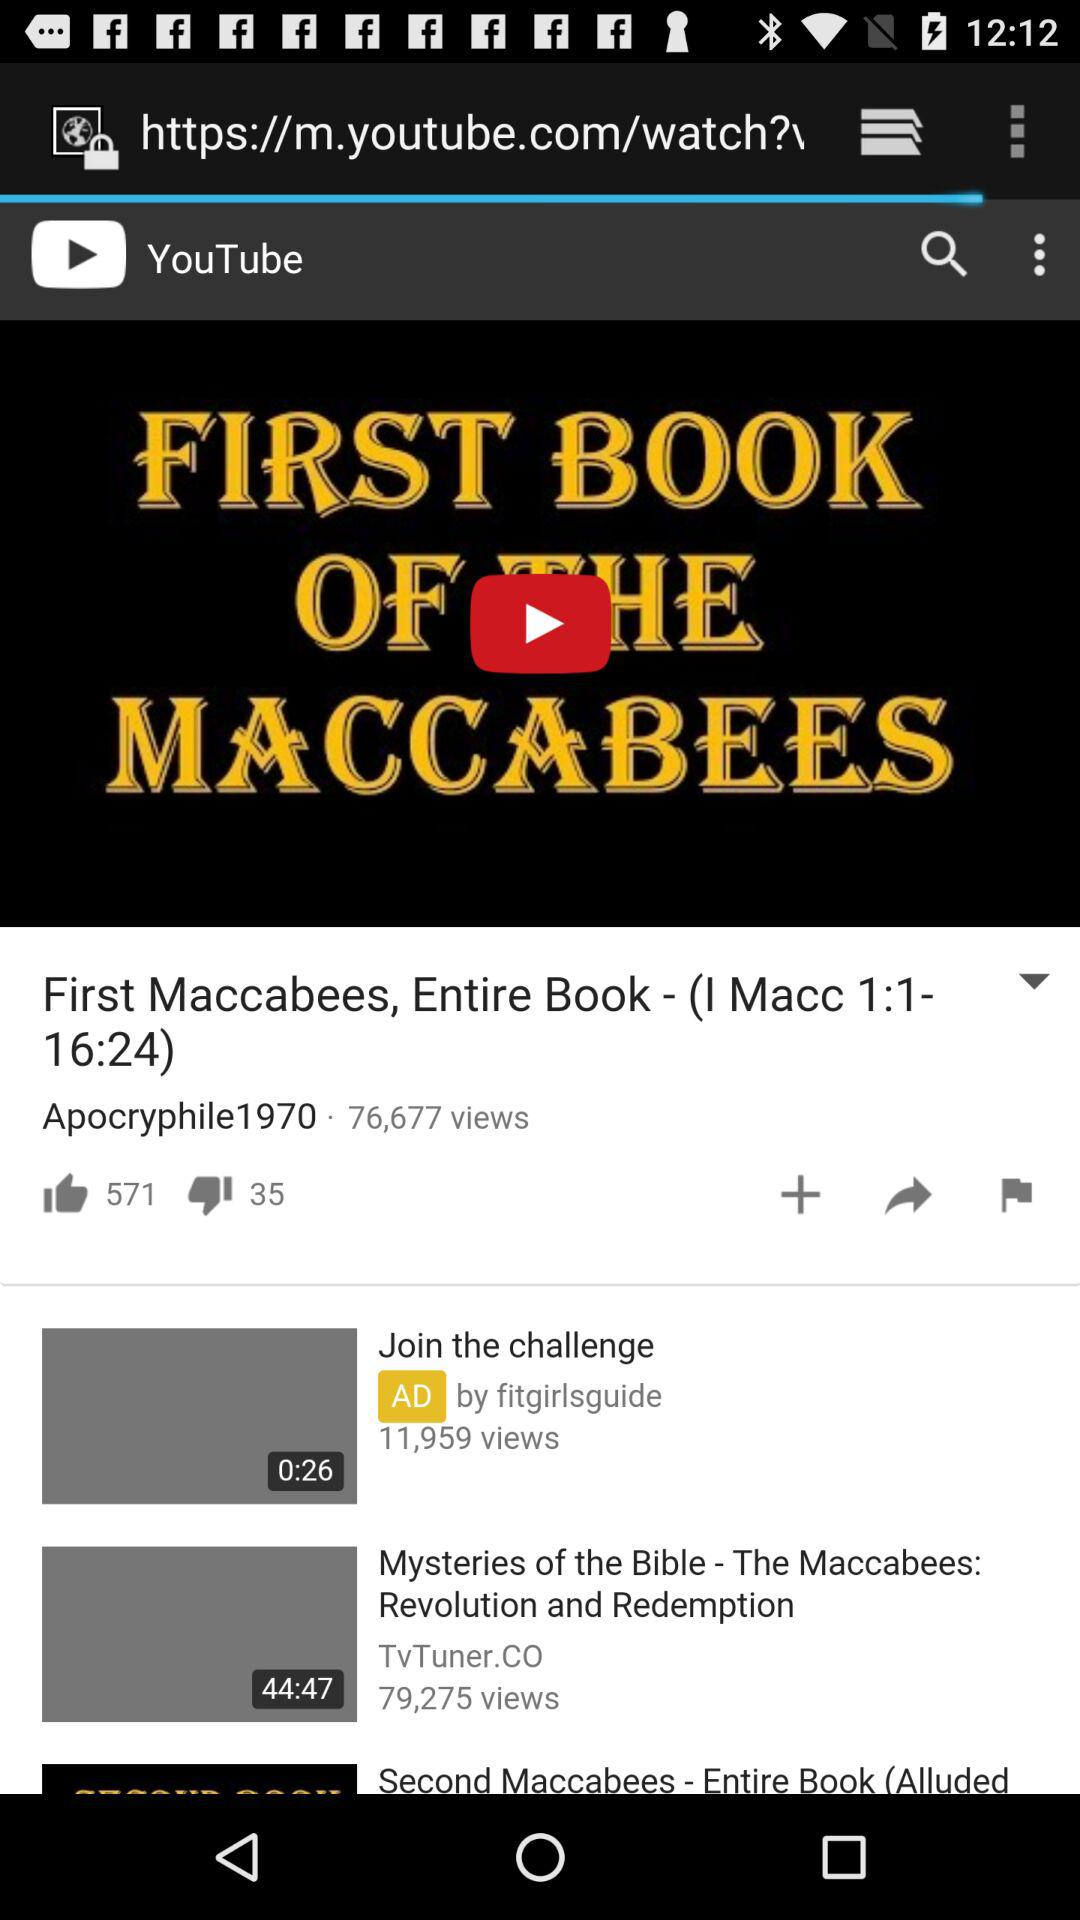What is the number of dislikes of the video? The number of dislikes of the video is 35. 